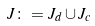<formula> <loc_0><loc_0><loc_500><loc_500>J \colon = J _ { d } \cup J _ { c }</formula> 